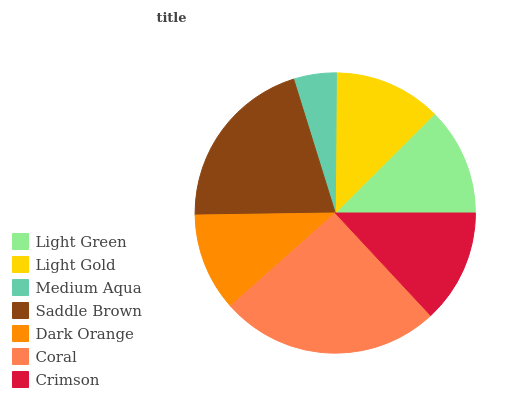Is Medium Aqua the minimum?
Answer yes or no. Yes. Is Coral the maximum?
Answer yes or no. Yes. Is Light Gold the minimum?
Answer yes or no. No. Is Light Gold the maximum?
Answer yes or no. No. Is Light Green greater than Light Gold?
Answer yes or no. Yes. Is Light Gold less than Light Green?
Answer yes or no. Yes. Is Light Gold greater than Light Green?
Answer yes or no. No. Is Light Green less than Light Gold?
Answer yes or no. No. Is Light Green the high median?
Answer yes or no. Yes. Is Light Green the low median?
Answer yes or no. Yes. Is Crimson the high median?
Answer yes or no. No. Is Medium Aqua the low median?
Answer yes or no. No. 